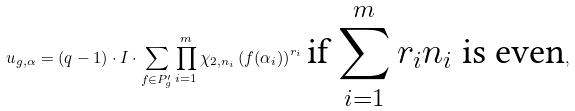Convert formula to latex. <formula><loc_0><loc_0><loc_500><loc_500>u _ { g , \alpha } = ( q - 1 ) \cdot I \cdot \sum _ { f \in P ^ { \prime } _ { g } } \prod _ { i = 1 } ^ { m } \chi _ { 2 , n _ { i } } \left ( f ( \alpha _ { i } ) \right ) ^ { r _ { i } } \, \text {if $\sum_{i=1}^{m} r_{i}n_{i}$ is even} ,</formula> 